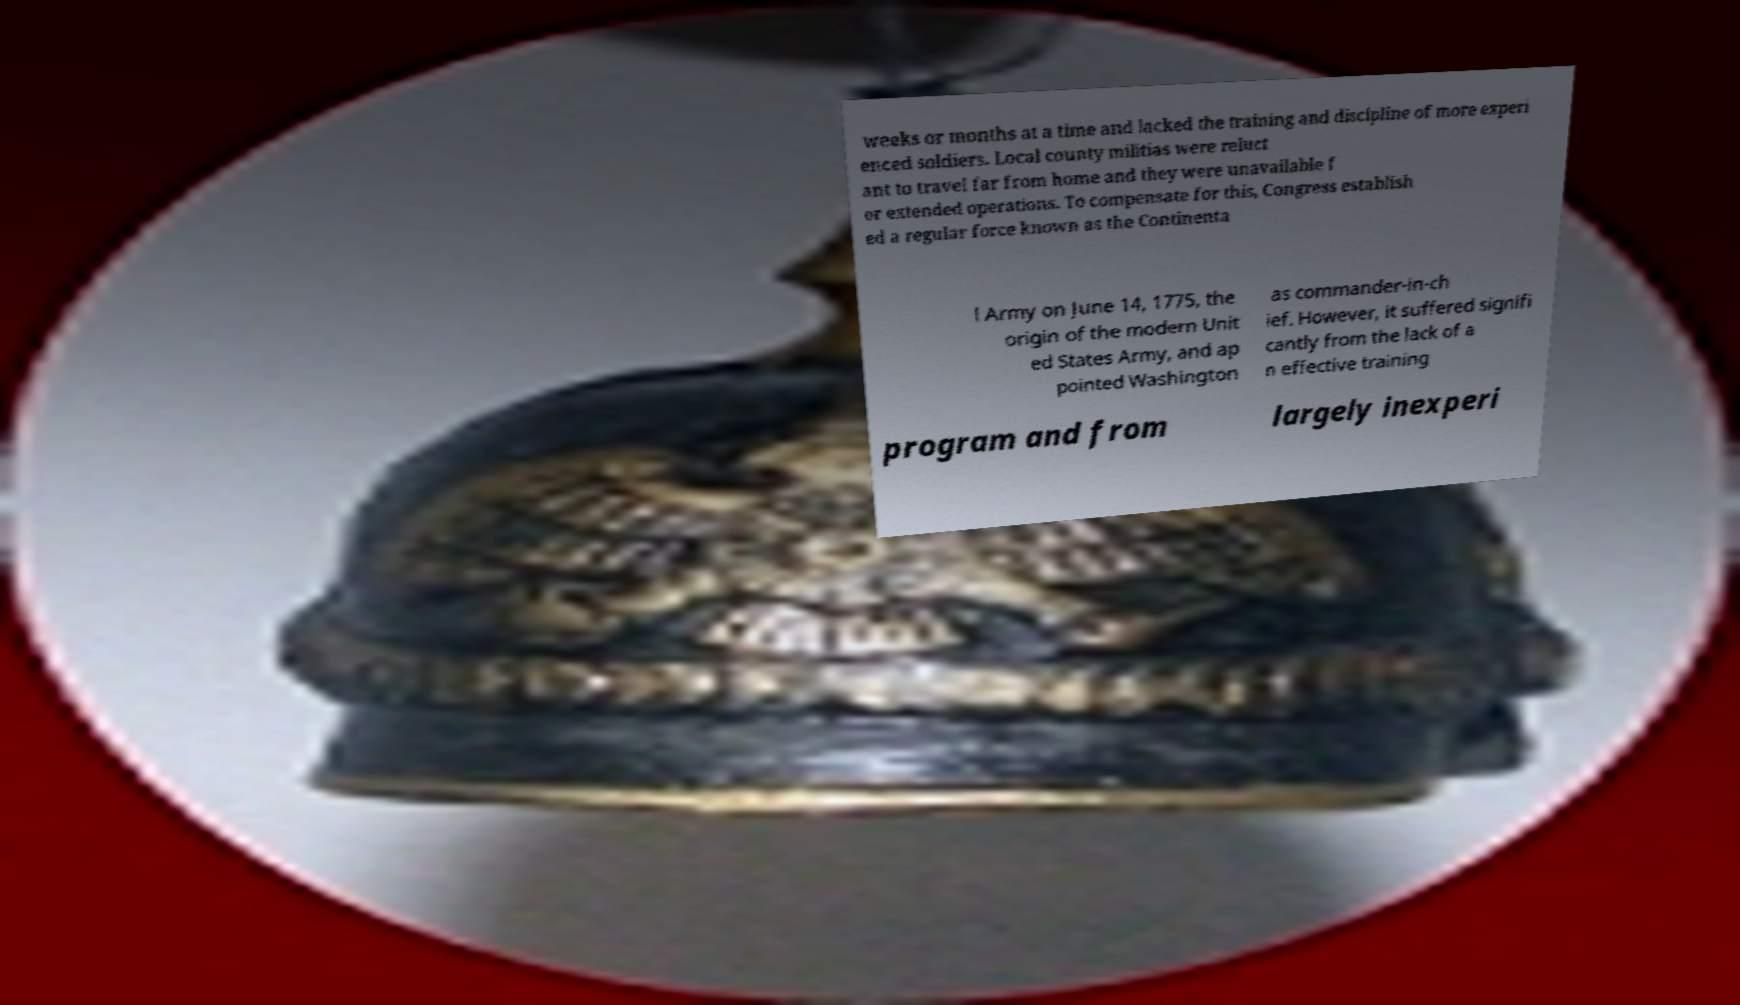What messages or text are displayed in this image? I need them in a readable, typed format. weeks or months at a time and lacked the training and discipline of more experi enced soldiers. Local county militias were reluct ant to travel far from home and they were unavailable f or extended operations. To compensate for this, Congress establish ed a regular force known as the Continenta l Army on June 14, 1775, the origin of the modern Unit ed States Army, and ap pointed Washington as commander-in-ch ief. However, it suffered signifi cantly from the lack of a n effective training program and from largely inexperi 